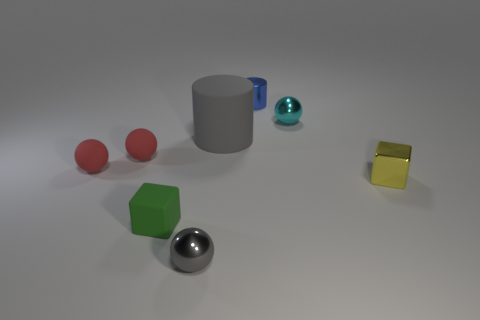Subtract all green balls. Subtract all yellow cylinders. How many balls are left? 4 Add 1 big cyan metal things. How many objects exist? 9 Subtract all tiny matte blocks. Subtract all large brown matte cylinders. How many objects are left? 7 Add 1 cyan things. How many cyan things are left? 2 Add 6 large gray rubber cylinders. How many large gray rubber cylinders exist? 7 Subtract 0 gray cubes. How many objects are left? 8 